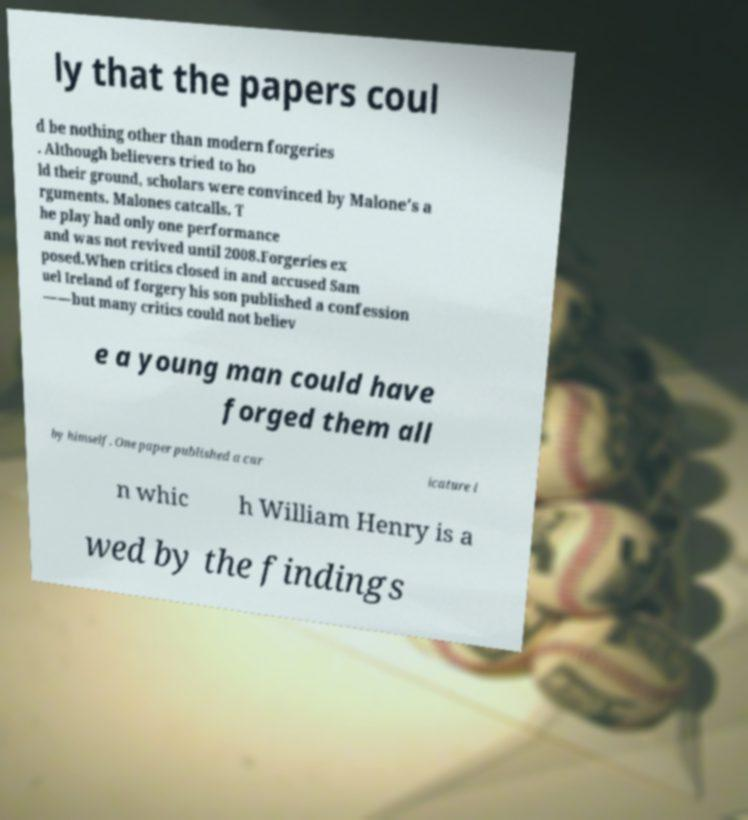What messages or text are displayed in this image? I need them in a readable, typed format. ly that the papers coul d be nothing other than modern forgeries . Although believers tried to ho ld their ground, scholars were convinced by Malone's a rguments. Malones catcalls. T he play had only one performance and was not revived until 2008.Forgeries ex posed.When critics closed in and accused Sam uel Ireland of forgery his son published a confession ——but many critics could not believ e a young man could have forged them all by himself. One paper published a car icature i n whic h William Henry is a wed by the findings 